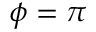Convert formula to latex. <formula><loc_0><loc_0><loc_500><loc_500>\phi = \pi</formula> 